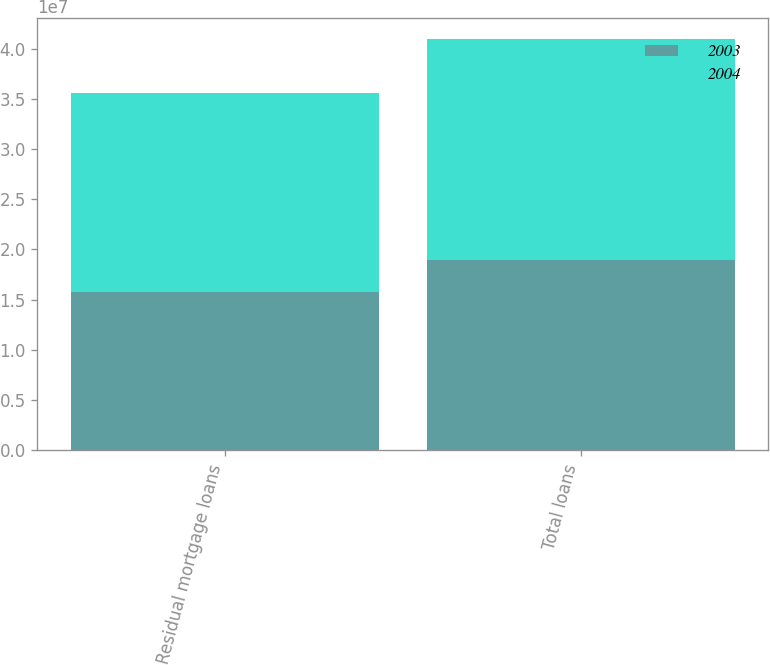<chart> <loc_0><loc_0><loc_500><loc_500><stacked_bar_chart><ecel><fcel>Residual mortgage loans<fcel>Total loans<nl><fcel>2003<fcel>1.5733e+07<fcel>1.89771e+07<nl><fcel>2004<fcel>1.98356e+07<fcel>2.20219e+07<nl></chart> 